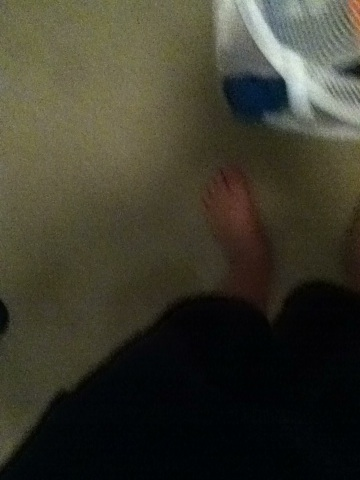Create a short, realistic scenario that could be taking place in this image. A person is sorting their laundry in their bedroom. They have just taken off their socks and are now standing barefoot on the carpet. They are about to gather the dirty clothes from the basket to take them downstairs to the laundry room. 